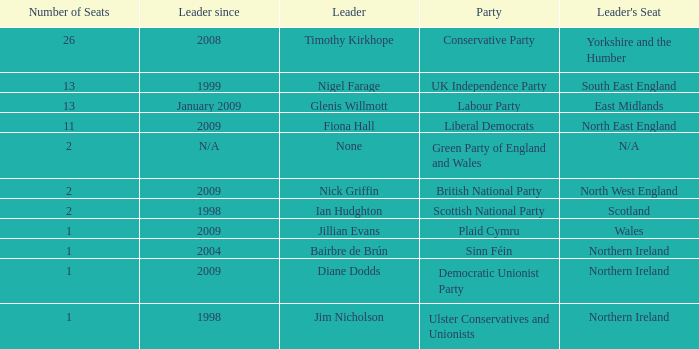Which party does Timothy Kirkhope lead? Conservative Party. 